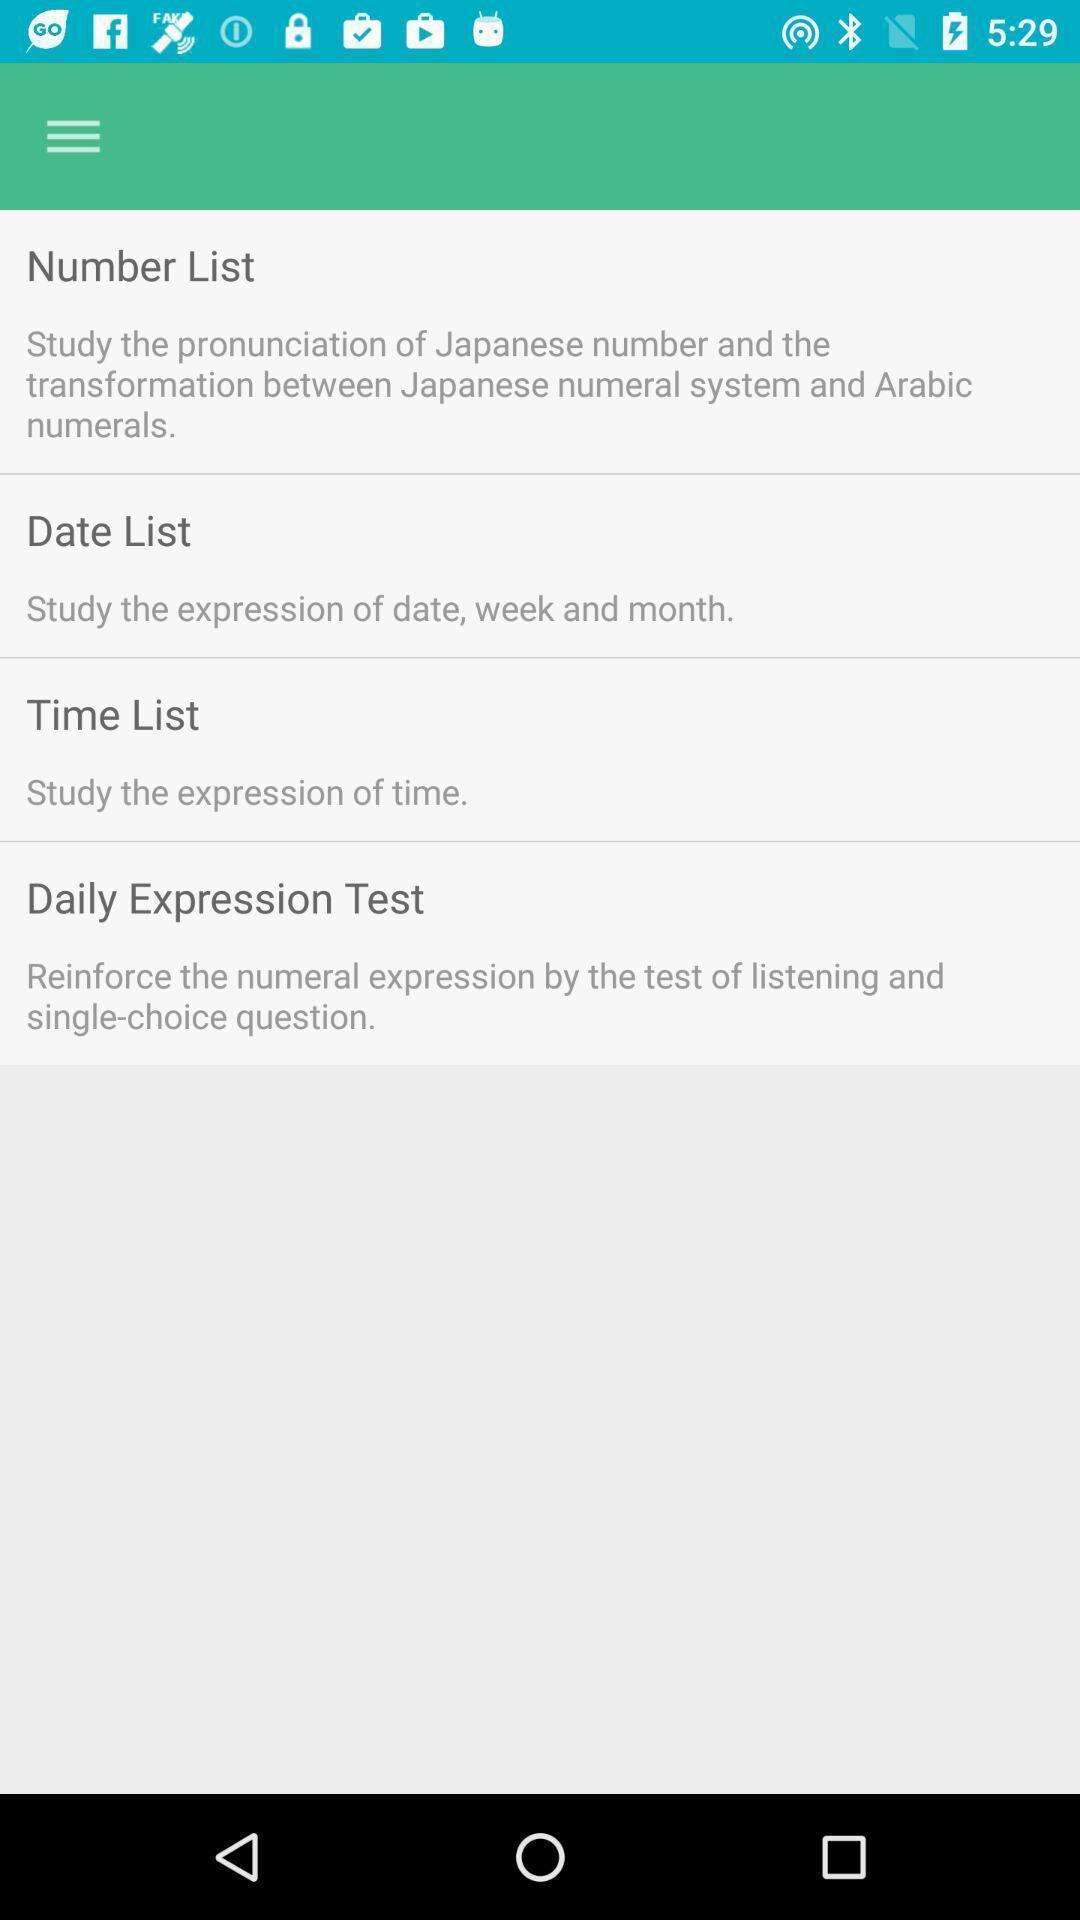Summarize the main components in this picture. Page shows the details of number date and time lists. 